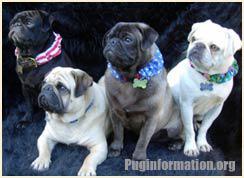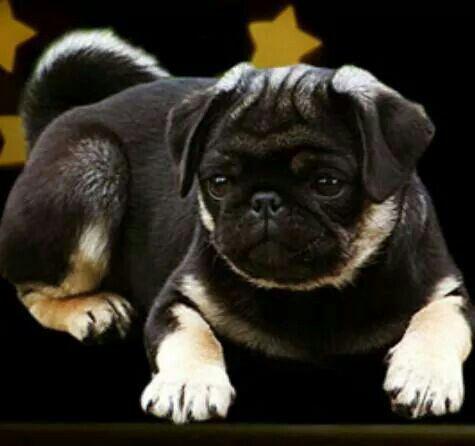The first image is the image on the left, the second image is the image on the right. Considering the images on both sides, is "There are at least 3 dogs." valid? Answer yes or no. Yes. The first image is the image on the left, the second image is the image on the right. Examine the images to the left and right. Is the description "There are two pups here." accurate? Answer yes or no. No. 